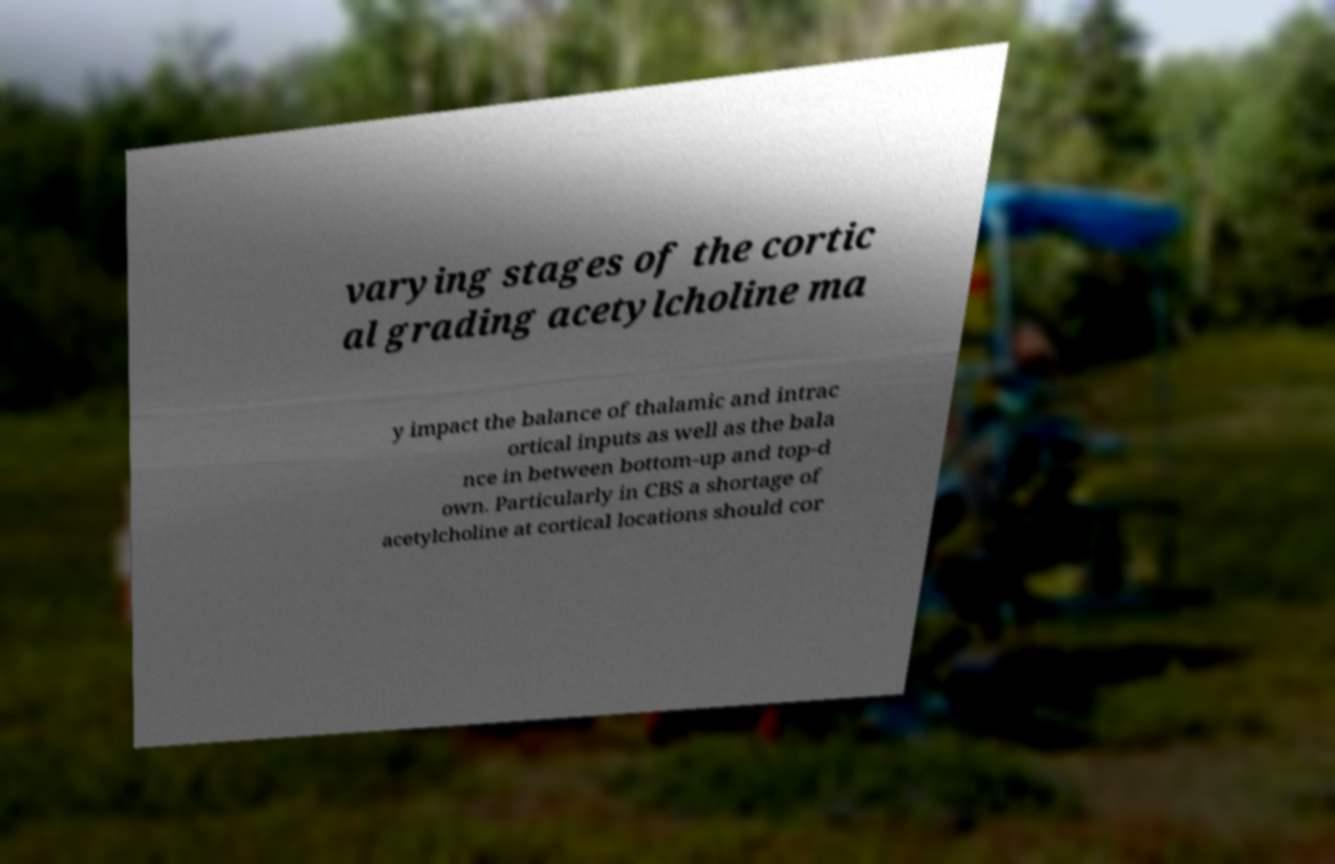What messages or text are displayed in this image? I need them in a readable, typed format. varying stages of the cortic al grading acetylcholine ma y impact the balance of thalamic and intrac ortical inputs as well as the bala nce in between bottom-up and top-d own. Particularly in CBS a shortage of acetylcholine at cortical locations should cor 